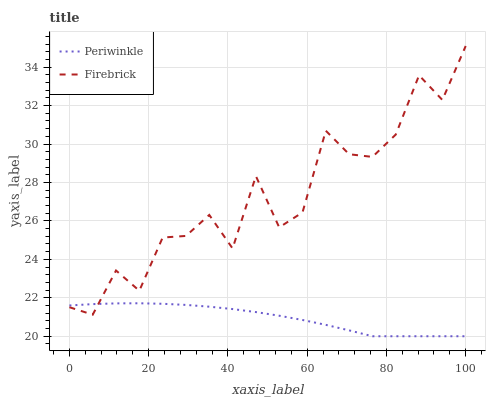Does Periwinkle have the minimum area under the curve?
Answer yes or no. Yes. Does Periwinkle have the maximum area under the curve?
Answer yes or no. No. Is Periwinkle the roughest?
Answer yes or no. No. Does Periwinkle have the highest value?
Answer yes or no. No. 